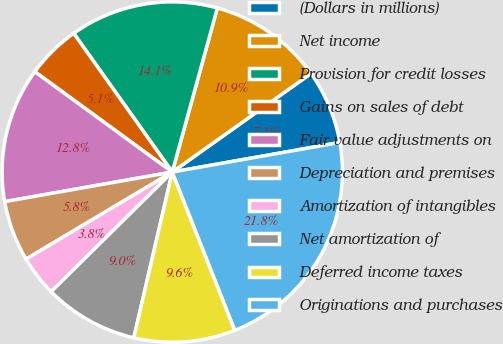Convert chart to OTSL. <chart><loc_0><loc_0><loc_500><loc_500><pie_chart><fcel>(Dollars in millions)<fcel>Net income<fcel>Provision for credit losses<fcel>Gains on sales of debt<fcel>Fair value adjustments on<fcel>Depreciation and premises<fcel>Amortization of intangibles<fcel>Net amortization of<fcel>Deferred income taxes<fcel>Originations and purchases<nl><fcel>7.05%<fcel>10.9%<fcel>14.1%<fcel>5.13%<fcel>12.82%<fcel>5.77%<fcel>3.85%<fcel>8.97%<fcel>9.62%<fcel>21.79%<nl></chart> 